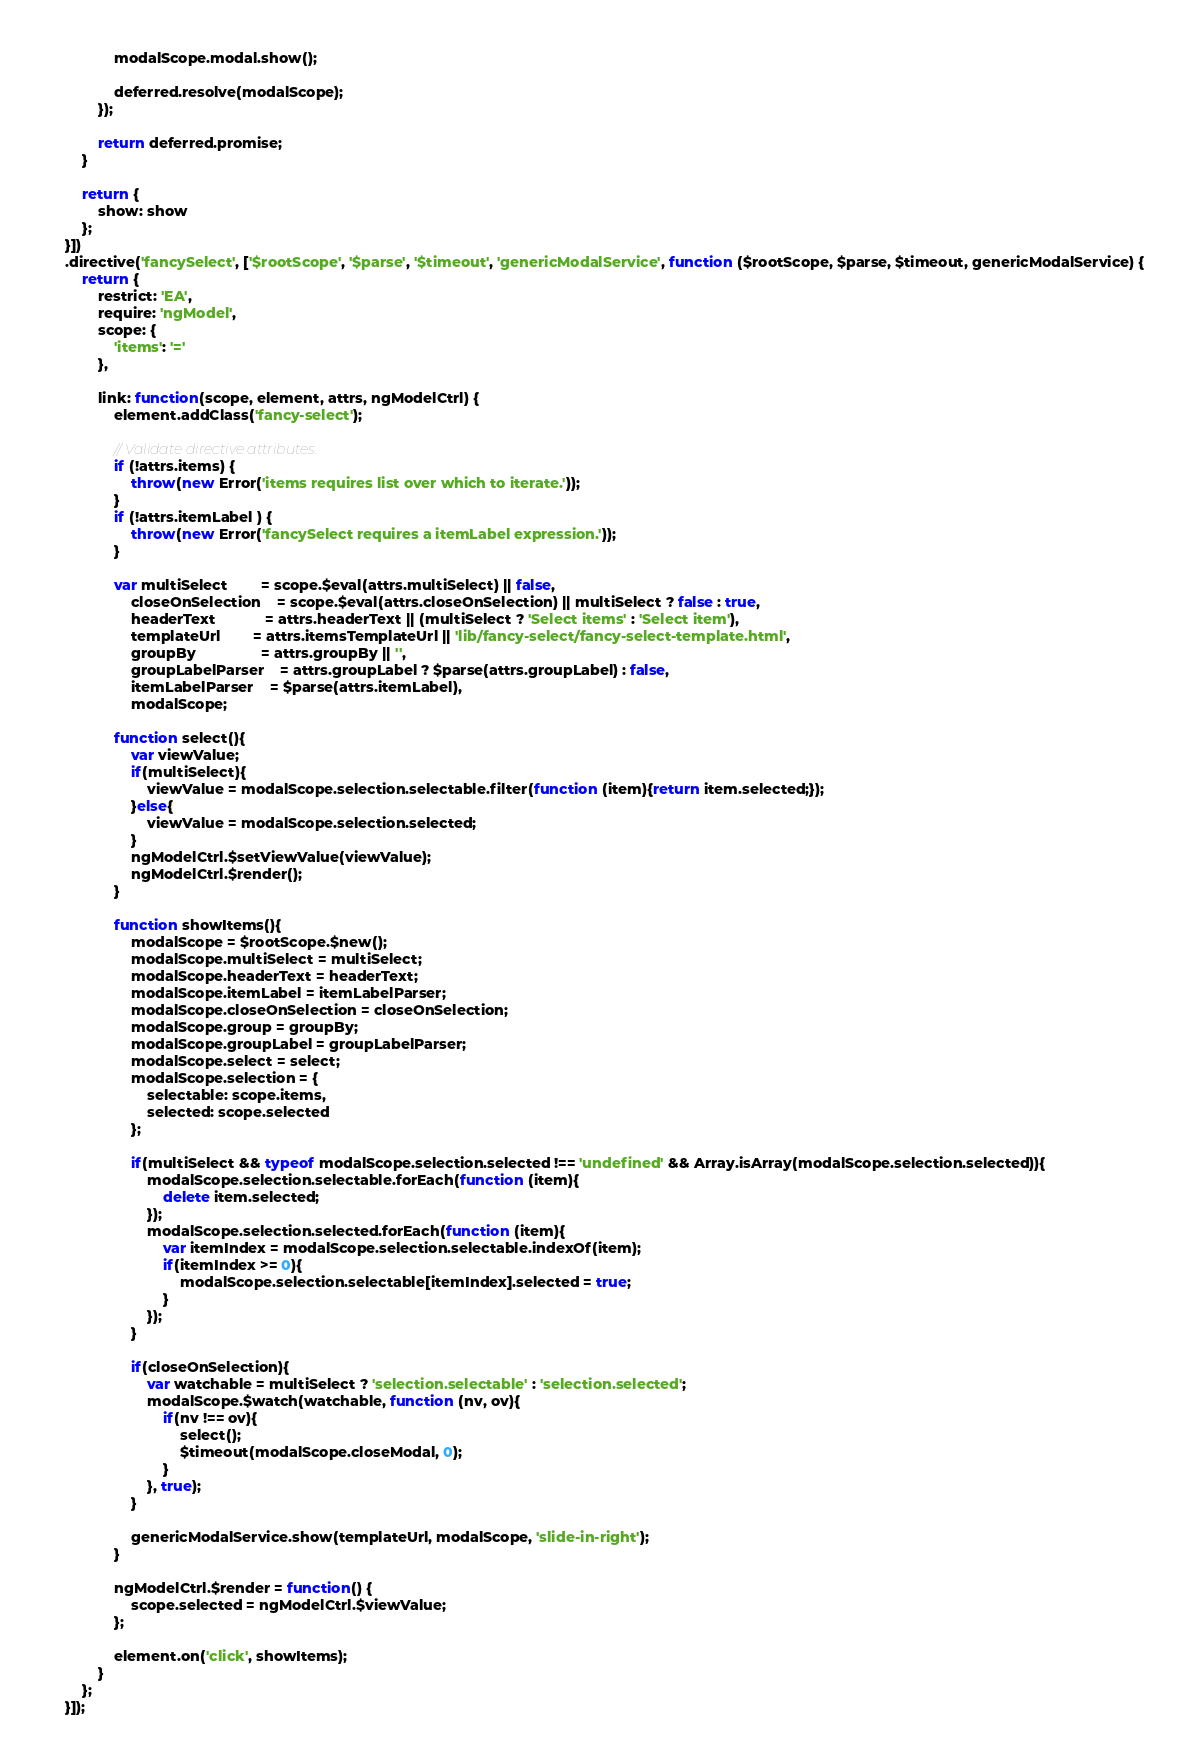<code> <loc_0><loc_0><loc_500><loc_500><_JavaScript_>                modalScope.modal.show();

                deferred.resolve(modalScope);
            });

            return deferred.promise;
        }

        return {
            show: show
        };
    }])
    .directive('fancySelect', ['$rootScope', '$parse', '$timeout', 'genericModalService', function ($rootScope, $parse, $timeout, genericModalService) {
        return {
            restrict: 'EA',
            require: 'ngModel',
            scope: {
                'items': '='
            },

            link: function(scope, element, attrs, ngModelCtrl) {
                element.addClass('fancy-select');

                // Validate directive attributes.
                if (!attrs.items) {
                    throw(new Error('items requires list over which to iterate.'));
                }
                if (!attrs.itemLabel ) {
                    throw(new Error('fancySelect requires a itemLabel expression.'));
                }

                var multiSelect 		= scope.$eval(attrs.multiSelect) || false,
                    closeOnSelection 	= scope.$eval(attrs.closeOnSelection) || multiSelect ? false : true,
                    headerText 			= attrs.headerText || (multiSelect ? 'Select items' : 'Select item'),
                    templateUrl 		= attrs.itemsTemplateUrl || 'lib/fancy-select/fancy-select-template.html',
                    groupBy				= attrs.groupBy || '',
                    groupLabelParser 	= attrs.groupLabel ? $parse(attrs.groupLabel) : false,
                    itemLabelParser 	= $parse(attrs.itemLabel),
                    modalScope;

                function select(){
                    var viewValue;
                    if(multiSelect){
                        viewValue = modalScope.selection.selectable.filter(function (item){return item.selected;});
                    }else{
                        viewValue = modalScope.selection.selected;
                    }
                    ngModelCtrl.$setViewValue(viewValue);
                    ngModelCtrl.$render();
                }

                function showItems(){
                    modalScope = $rootScope.$new();
                    modalScope.multiSelect = multiSelect;
                    modalScope.headerText = headerText;
                    modalScope.itemLabel = itemLabelParser;
                    modalScope.closeOnSelection = closeOnSelection;
                    modalScope.group = groupBy;
                    modalScope.groupLabel = groupLabelParser;
                    modalScope.select = select;
                    modalScope.selection = {
                        selectable: scope.items,
                        selected: scope.selected
                    };

                    if(multiSelect && typeof modalScope.selection.selected !== 'undefined' && Array.isArray(modalScope.selection.selected)){
                        modalScope.selection.selectable.forEach(function (item){
                            delete item.selected;
                        });
                        modalScope.selection.selected.forEach(function (item){
                            var itemIndex = modalScope.selection.selectable.indexOf(item);
                            if(itemIndex >= 0){
                                modalScope.selection.selectable[itemIndex].selected = true;
                            }
                        });
                    }

                    if(closeOnSelection){
                        var watchable = multiSelect ? 'selection.selectable' : 'selection.selected';
                        modalScope.$watch(watchable, function (nv, ov){
                            if(nv !== ov){
                                select();
                                $timeout(modalScope.closeModal, 0);
                            }
                        }, true);
                    }

                    genericModalService.show(templateUrl, modalScope, 'slide-in-right');
                }

                ngModelCtrl.$render = function() {
                    scope.selected = ngModelCtrl.$viewValue;
                };

                element.on('click', showItems);
            }
        };
    }]);
</code> 